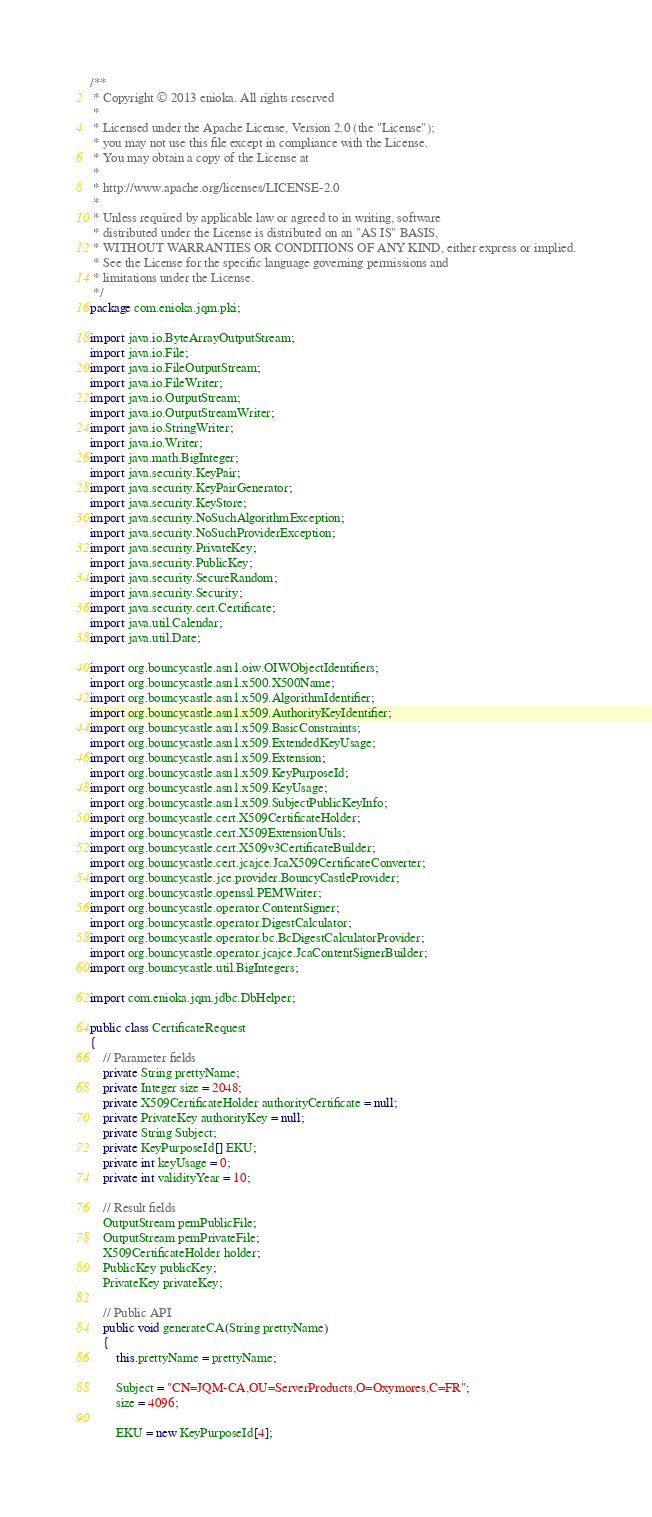Convert code to text. <code><loc_0><loc_0><loc_500><loc_500><_Java_>/**
 * Copyright © 2013 enioka. All rights reserved
 *
 * Licensed under the Apache License, Version 2.0 (the "License");
 * you may not use this file except in compliance with the License.
 * You may obtain a copy of the License at
 *
 * http://www.apache.org/licenses/LICENSE-2.0
 *
 * Unless required by applicable law or agreed to in writing, software
 * distributed under the License is distributed on an "AS IS" BASIS,
 * WITHOUT WARRANTIES OR CONDITIONS OF ANY KIND, either express or implied.
 * See the License for the specific language governing permissions and
 * limitations under the License.
 */
package com.enioka.jqm.pki;

import java.io.ByteArrayOutputStream;
import java.io.File;
import java.io.FileOutputStream;
import java.io.FileWriter;
import java.io.OutputStream;
import java.io.OutputStreamWriter;
import java.io.StringWriter;
import java.io.Writer;
import java.math.BigInteger;
import java.security.KeyPair;
import java.security.KeyPairGenerator;
import java.security.KeyStore;
import java.security.NoSuchAlgorithmException;
import java.security.NoSuchProviderException;
import java.security.PrivateKey;
import java.security.PublicKey;
import java.security.SecureRandom;
import java.security.Security;
import java.security.cert.Certificate;
import java.util.Calendar;
import java.util.Date;

import org.bouncycastle.asn1.oiw.OIWObjectIdentifiers;
import org.bouncycastle.asn1.x500.X500Name;
import org.bouncycastle.asn1.x509.AlgorithmIdentifier;
import org.bouncycastle.asn1.x509.AuthorityKeyIdentifier;
import org.bouncycastle.asn1.x509.BasicConstraints;
import org.bouncycastle.asn1.x509.ExtendedKeyUsage;
import org.bouncycastle.asn1.x509.Extension;
import org.bouncycastle.asn1.x509.KeyPurposeId;
import org.bouncycastle.asn1.x509.KeyUsage;
import org.bouncycastle.asn1.x509.SubjectPublicKeyInfo;
import org.bouncycastle.cert.X509CertificateHolder;
import org.bouncycastle.cert.X509ExtensionUtils;
import org.bouncycastle.cert.X509v3CertificateBuilder;
import org.bouncycastle.cert.jcajce.JcaX509CertificateConverter;
import org.bouncycastle.jce.provider.BouncyCastleProvider;
import org.bouncycastle.openssl.PEMWriter;
import org.bouncycastle.operator.ContentSigner;
import org.bouncycastle.operator.DigestCalculator;
import org.bouncycastle.operator.bc.BcDigestCalculatorProvider;
import org.bouncycastle.operator.jcajce.JcaContentSignerBuilder;
import org.bouncycastle.util.BigIntegers;

import com.enioka.jqm.jdbc.DbHelper;

public class CertificateRequest
{
    // Parameter fields
    private String prettyName;
    private Integer size = 2048;
    private X509CertificateHolder authorityCertificate = null;
    private PrivateKey authorityKey = null;
    private String Subject;
    private KeyPurposeId[] EKU;
    private int keyUsage = 0;
    private int validityYear = 10;

    // Result fields
    OutputStream pemPublicFile;
    OutputStream pemPrivateFile;
    X509CertificateHolder holder;
    PublicKey publicKey;
    PrivateKey privateKey;

    // Public API
    public void generateCA(String prettyName)
    {
        this.prettyName = prettyName;

        Subject = "CN=JQM-CA,OU=ServerProducts,O=Oxymores,C=FR";
        size = 4096;

        EKU = new KeyPurposeId[4];</code> 